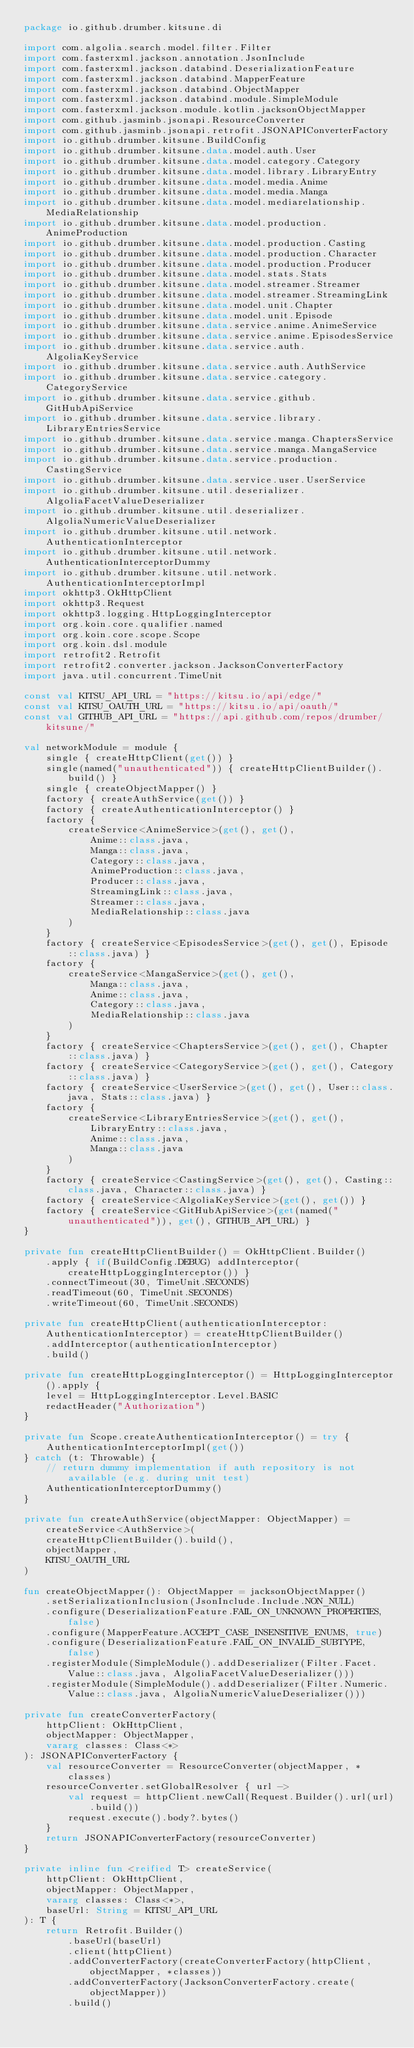<code> <loc_0><loc_0><loc_500><loc_500><_Kotlin_>package io.github.drumber.kitsune.di

import com.algolia.search.model.filter.Filter
import com.fasterxml.jackson.annotation.JsonInclude
import com.fasterxml.jackson.databind.DeserializationFeature
import com.fasterxml.jackson.databind.MapperFeature
import com.fasterxml.jackson.databind.ObjectMapper
import com.fasterxml.jackson.databind.module.SimpleModule
import com.fasterxml.jackson.module.kotlin.jacksonObjectMapper
import com.github.jasminb.jsonapi.ResourceConverter
import com.github.jasminb.jsonapi.retrofit.JSONAPIConverterFactory
import io.github.drumber.kitsune.BuildConfig
import io.github.drumber.kitsune.data.model.auth.User
import io.github.drumber.kitsune.data.model.category.Category
import io.github.drumber.kitsune.data.model.library.LibraryEntry
import io.github.drumber.kitsune.data.model.media.Anime
import io.github.drumber.kitsune.data.model.media.Manga
import io.github.drumber.kitsune.data.model.mediarelationship.MediaRelationship
import io.github.drumber.kitsune.data.model.production.AnimeProduction
import io.github.drumber.kitsune.data.model.production.Casting
import io.github.drumber.kitsune.data.model.production.Character
import io.github.drumber.kitsune.data.model.production.Producer
import io.github.drumber.kitsune.data.model.stats.Stats
import io.github.drumber.kitsune.data.model.streamer.Streamer
import io.github.drumber.kitsune.data.model.streamer.StreamingLink
import io.github.drumber.kitsune.data.model.unit.Chapter
import io.github.drumber.kitsune.data.model.unit.Episode
import io.github.drumber.kitsune.data.service.anime.AnimeService
import io.github.drumber.kitsune.data.service.anime.EpisodesService
import io.github.drumber.kitsune.data.service.auth.AlgoliaKeyService
import io.github.drumber.kitsune.data.service.auth.AuthService
import io.github.drumber.kitsune.data.service.category.CategoryService
import io.github.drumber.kitsune.data.service.github.GitHubApiService
import io.github.drumber.kitsune.data.service.library.LibraryEntriesService
import io.github.drumber.kitsune.data.service.manga.ChaptersService
import io.github.drumber.kitsune.data.service.manga.MangaService
import io.github.drumber.kitsune.data.service.production.CastingService
import io.github.drumber.kitsune.data.service.user.UserService
import io.github.drumber.kitsune.util.deserializer.AlgoliaFacetValueDeserializer
import io.github.drumber.kitsune.util.deserializer.AlgoliaNumericValueDeserializer
import io.github.drumber.kitsune.util.network.AuthenticationInterceptor
import io.github.drumber.kitsune.util.network.AuthenticationInterceptorDummy
import io.github.drumber.kitsune.util.network.AuthenticationInterceptorImpl
import okhttp3.OkHttpClient
import okhttp3.Request
import okhttp3.logging.HttpLoggingInterceptor
import org.koin.core.qualifier.named
import org.koin.core.scope.Scope
import org.koin.dsl.module
import retrofit2.Retrofit
import retrofit2.converter.jackson.JacksonConverterFactory
import java.util.concurrent.TimeUnit

const val KITSU_API_URL = "https://kitsu.io/api/edge/"
const val KITSU_OAUTH_URL = "https://kitsu.io/api/oauth/"
const val GITHUB_API_URL = "https://api.github.com/repos/drumber/kitsune/"

val networkModule = module {
    single { createHttpClient(get()) }
    single(named("unauthenticated")) { createHttpClientBuilder().build() }
    single { createObjectMapper() }
    factory { createAuthService(get()) }
    factory { createAuthenticationInterceptor() }
    factory {
        createService<AnimeService>(get(), get(),
            Anime::class.java,
            Manga::class.java,
            Category::class.java,
            AnimeProduction::class.java,
            Producer::class.java,
            StreamingLink::class.java,
            Streamer::class.java,
            MediaRelationship::class.java
        )
    }
    factory { createService<EpisodesService>(get(), get(), Episode::class.java) }
    factory {
        createService<MangaService>(get(), get(),
            Manga::class.java,
            Anime::class.java,
            Category::class.java,
            MediaRelationship::class.java
        )
    }
    factory { createService<ChaptersService>(get(), get(), Chapter::class.java) }
    factory { createService<CategoryService>(get(), get(), Category::class.java) }
    factory { createService<UserService>(get(), get(), User::class.java, Stats::class.java) }
    factory {
        createService<LibraryEntriesService>(get(), get(),
            LibraryEntry::class.java,
            Anime::class.java,
            Manga::class.java
        )
    }
    factory { createService<CastingService>(get(), get(), Casting::class.java, Character::class.java) }
    factory { createService<AlgoliaKeyService>(get(), get()) }
    factory { createService<GitHubApiService>(get(named("unauthenticated")), get(), GITHUB_API_URL) }
}

private fun createHttpClientBuilder() = OkHttpClient.Builder()
    .apply { if(BuildConfig.DEBUG) addInterceptor(createHttpLoggingInterceptor()) }
    .connectTimeout(30, TimeUnit.SECONDS)
    .readTimeout(60, TimeUnit.SECONDS)
    .writeTimeout(60, TimeUnit.SECONDS)

private fun createHttpClient(authenticationInterceptor: AuthenticationInterceptor) = createHttpClientBuilder()
    .addInterceptor(authenticationInterceptor)
    .build()

private fun createHttpLoggingInterceptor() = HttpLoggingInterceptor().apply {
    level = HttpLoggingInterceptor.Level.BASIC
    redactHeader("Authorization")
}

private fun Scope.createAuthenticationInterceptor() = try {
    AuthenticationInterceptorImpl(get())
} catch (t: Throwable) {
    // return dummy implementation if auth repository is not available (e.g. during unit test)
    AuthenticationInterceptorDummy()
}

private fun createAuthService(objectMapper: ObjectMapper) = createService<AuthService>(
    createHttpClientBuilder().build(),
    objectMapper,
    KITSU_OAUTH_URL
)

fun createObjectMapper(): ObjectMapper = jacksonObjectMapper()
    .setSerializationInclusion(JsonInclude.Include.NON_NULL)
    .configure(DeserializationFeature.FAIL_ON_UNKNOWN_PROPERTIES, false)
    .configure(MapperFeature.ACCEPT_CASE_INSENSITIVE_ENUMS, true)
    .configure(DeserializationFeature.FAIL_ON_INVALID_SUBTYPE, false)
    .registerModule(SimpleModule().addDeserializer(Filter.Facet.Value::class.java, AlgoliaFacetValueDeserializer()))
    .registerModule(SimpleModule().addDeserializer(Filter.Numeric.Value::class.java, AlgoliaNumericValueDeserializer()))

private fun createConverterFactory(
    httpClient: OkHttpClient,
    objectMapper: ObjectMapper,
    vararg classes: Class<*>
): JSONAPIConverterFactory {
    val resourceConverter = ResourceConverter(objectMapper, *classes)
    resourceConverter.setGlobalResolver { url ->
        val request = httpClient.newCall(Request.Builder().url(url).build())
        request.execute().body?.bytes()
    }
    return JSONAPIConverterFactory(resourceConverter)
}

private inline fun <reified T> createService(
    httpClient: OkHttpClient,
    objectMapper: ObjectMapper,
    vararg classes: Class<*>,
    baseUrl: String = KITSU_API_URL
): T {
    return Retrofit.Builder()
        .baseUrl(baseUrl)
        .client(httpClient)
        .addConverterFactory(createConverterFactory(httpClient, objectMapper, *classes))
        .addConverterFactory(JacksonConverterFactory.create(objectMapper))
        .build()</code> 